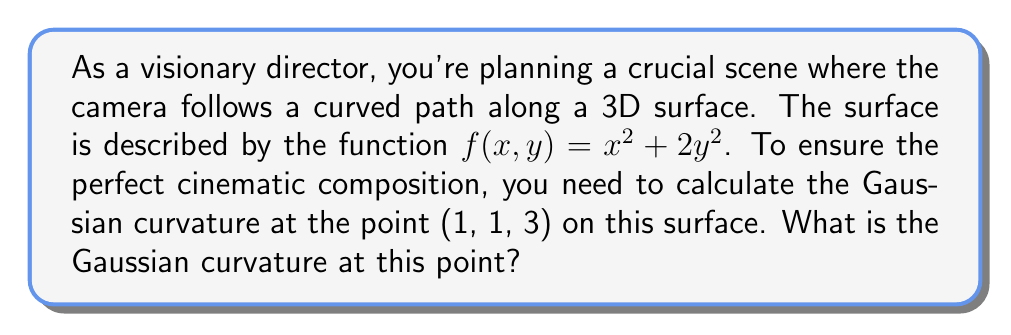Could you help me with this problem? To calculate the Gaussian curvature of a surface described by $z = f(x,y)$ at a point, we need to follow these steps:

1) First, we need to calculate the first and second partial derivatives of $f(x,y)$:

   $f_x = \frac{\partial f}{\partial x} = 2x$
   $f_y = \frac{\partial f}{\partial y} = 4y$
   $f_{xx} = \frac{\partial^2 f}{\partial x^2} = 2$
   $f_{yy} = \frac{\partial^2 f}{\partial y^2} = 4$
   $f_{xy} = f_{yx} = \frac{\partial^2 f}{\partial x \partial y} = 0$

2) The Gaussian curvature $K$ is given by the formula:

   $$K = \frac{f_{xx}f_{yy} - f_{xy}^2}{(1 + f_x^2 + f_y^2)^2}$$

3) Now, let's evaluate these at the point (1, 1, 3):

   $f_x(1,1) = 2$
   $f_y(1,1) = 4$
   $f_{xx}(1,1) = 2$
   $f_{yy}(1,1) = 4$
   $f_{xy}(1,1) = 0$

4) Substituting these values into the formula:

   $$K = \frac{2 \cdot 4 - 0^2}{(1 + 2^2 + 4^2)^2} = \frac{8}{(1 + 4 + 16)^2} = \frac{8}{21^2}$$

5) Simplifying:

   $$K = \frac{8}{441} \approx 0.018141$$

This Gaussian curvature value indicates how much the surface deviates from being flat at the given point, which is crucial for understanding how the camera movement will appear on screen.
Answer: The Gaussian curvature at the point (1, 1, 3) on the surface $f(x,y) = x^2 + 2y^2$ is $\frac{8}{441} \approx 0.018141$. 